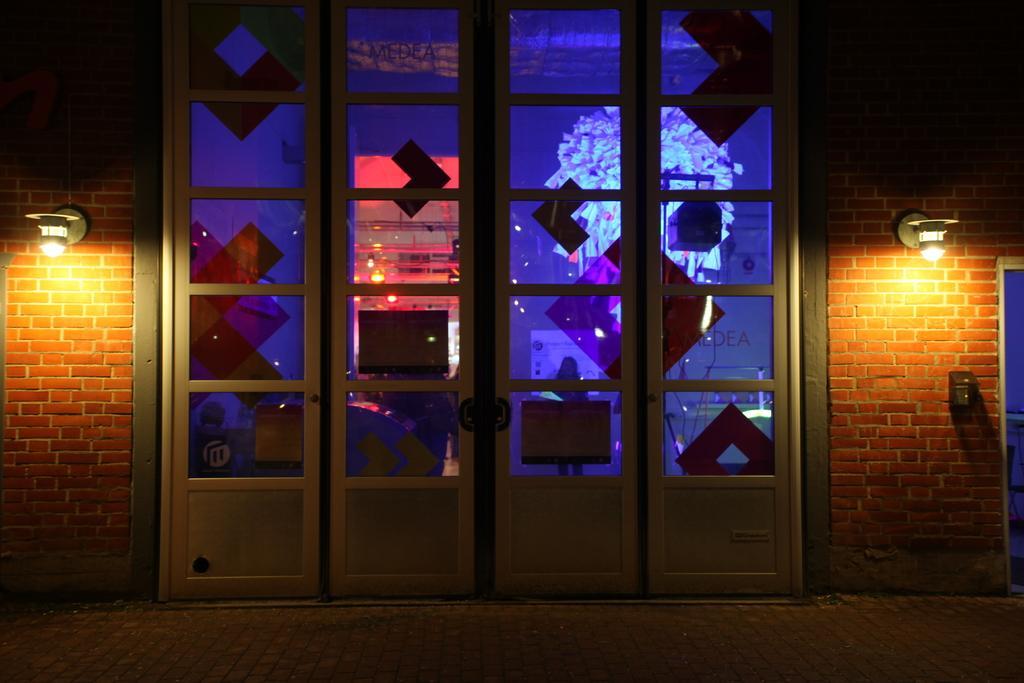Please provide a concise description of this image. In this image we can see the glass doors. And we can see the lights. And we can see the brick wall. 